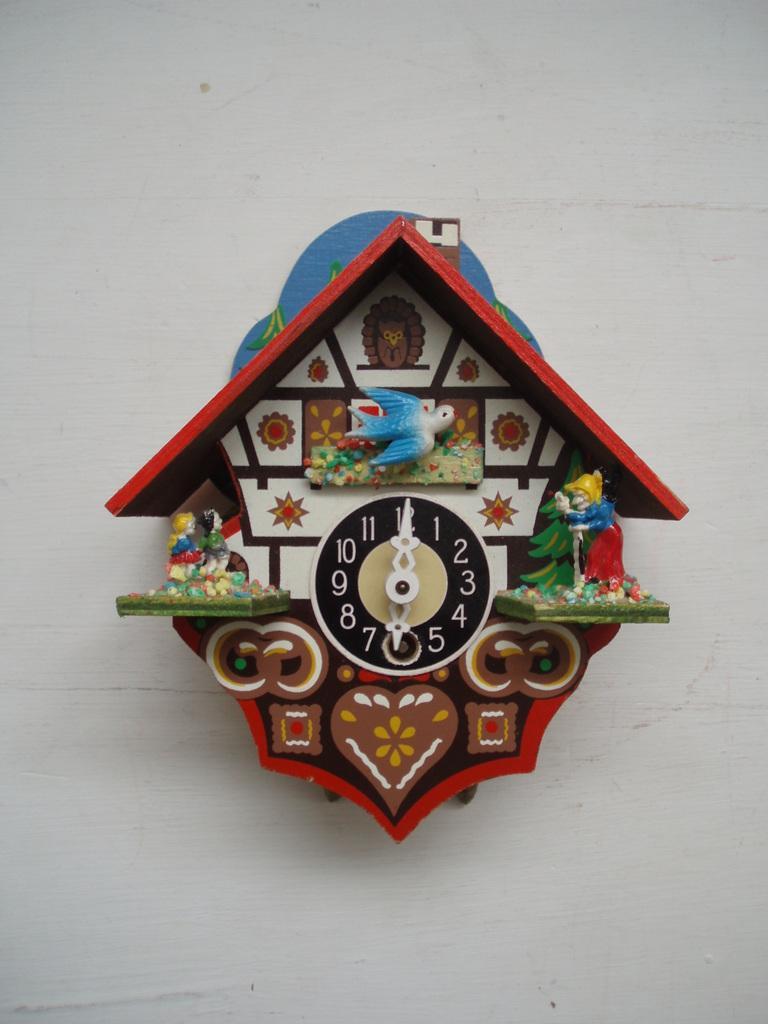How would you summarize this image in a sentence or two? In this image, we can see a clock which is attached to a wall. The wall is in white color. 